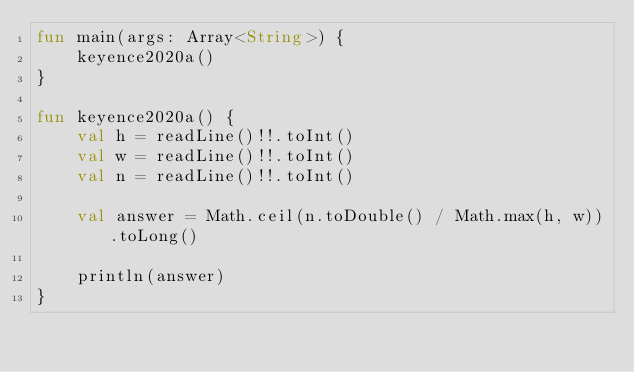Convert code to text. <code><loc_0><loc_0><loc_500><loc_500><_Kotlin_>fun main(args: Array<String>) {
    keyence2020a()
}

fun keyence2020a() {
    val h = readLine()!!.toInt()
    val w = readLine()!!.toInt()
    val n = readLine()!!.toInt()

    val answer = Math.ceil(n.toDouble() / Math.max(h, w)).toLong()

    println(answer)
}
</code> 